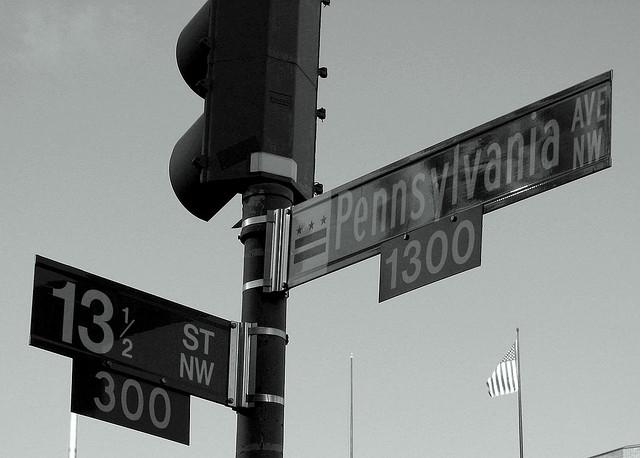Why does this black and white photo of a street sign say thirteen an half st?
Be succinct. It just does. What color are the skies?
Quick response, please. Gray. What Avenue is a number in the teens?
Answer briefly. 13. What name is on the street sign?
Write a very short answer. Pennsylvania. What color is the street sign?
Concise answer only. Black. What 2 numbers are seen?
Concise answer only. 13. What building is at this address?
Concise answer only. White house. What is the first letter of the street name?
Short answer required. P. 